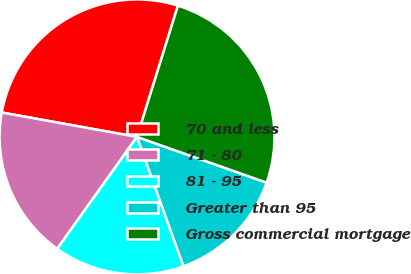Convert chart to OTSL. <chart><loc_0><loc_0><loc_500><loc_500><pie_chart><fcel>70 and less<fcel>71 - 80<fcel>81 - 95<fcel>Greater than 95<fcel>Gross commercial mortgage<nl><fcel>26.97%<fcel>17.98%<fcel>15.35%<fcel>14.11%<fcel>25.59%<nl></chart> 